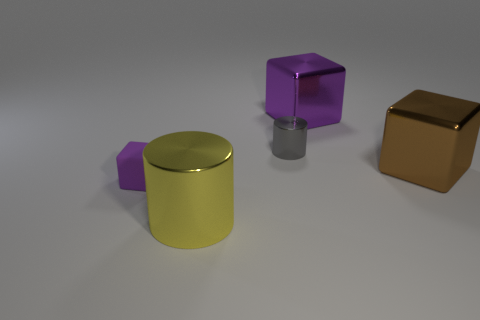What number of things are either cylinders that are in front of the gray cylinder or cylinders that are in front of the tiny cylinder?
Offer a terse response. 1. There is a purple cube left of the object behind the small object that is behind the tiny purple matte block; how big is it?
Make the answer very short. Small. Are there the same number of tiny gray cylinders that are in front of the gray metal cylinder and big brown things?
Make the answer very short. No. Is there anything else that has the same shape as the tiny metal object?
Offer a very short reply. Yes. Do the big yellow object and the purple thing to the right of the large yellow metal cylinder have the same shape?
Your answer should be compact. No. There is another metallic object that is the same shape as the purple metallic thing; what is its size?
Provide a succinct answer. Large. How many other things are there of the same material as the small cube?
Provide a short and direct response. 0. What is the material of the big yellow cylinder?
Your answer should be very brief. Metal. There is a block left of the yellow shiny thing; is its color the same as the large thing on the left side of the large purple metal block?
Offer a terse response. No. Is the number of matte objects that are on the left side of the yellow thing greater than the number of big gray metal cylinders?
Give a very brief answer. Yes. 